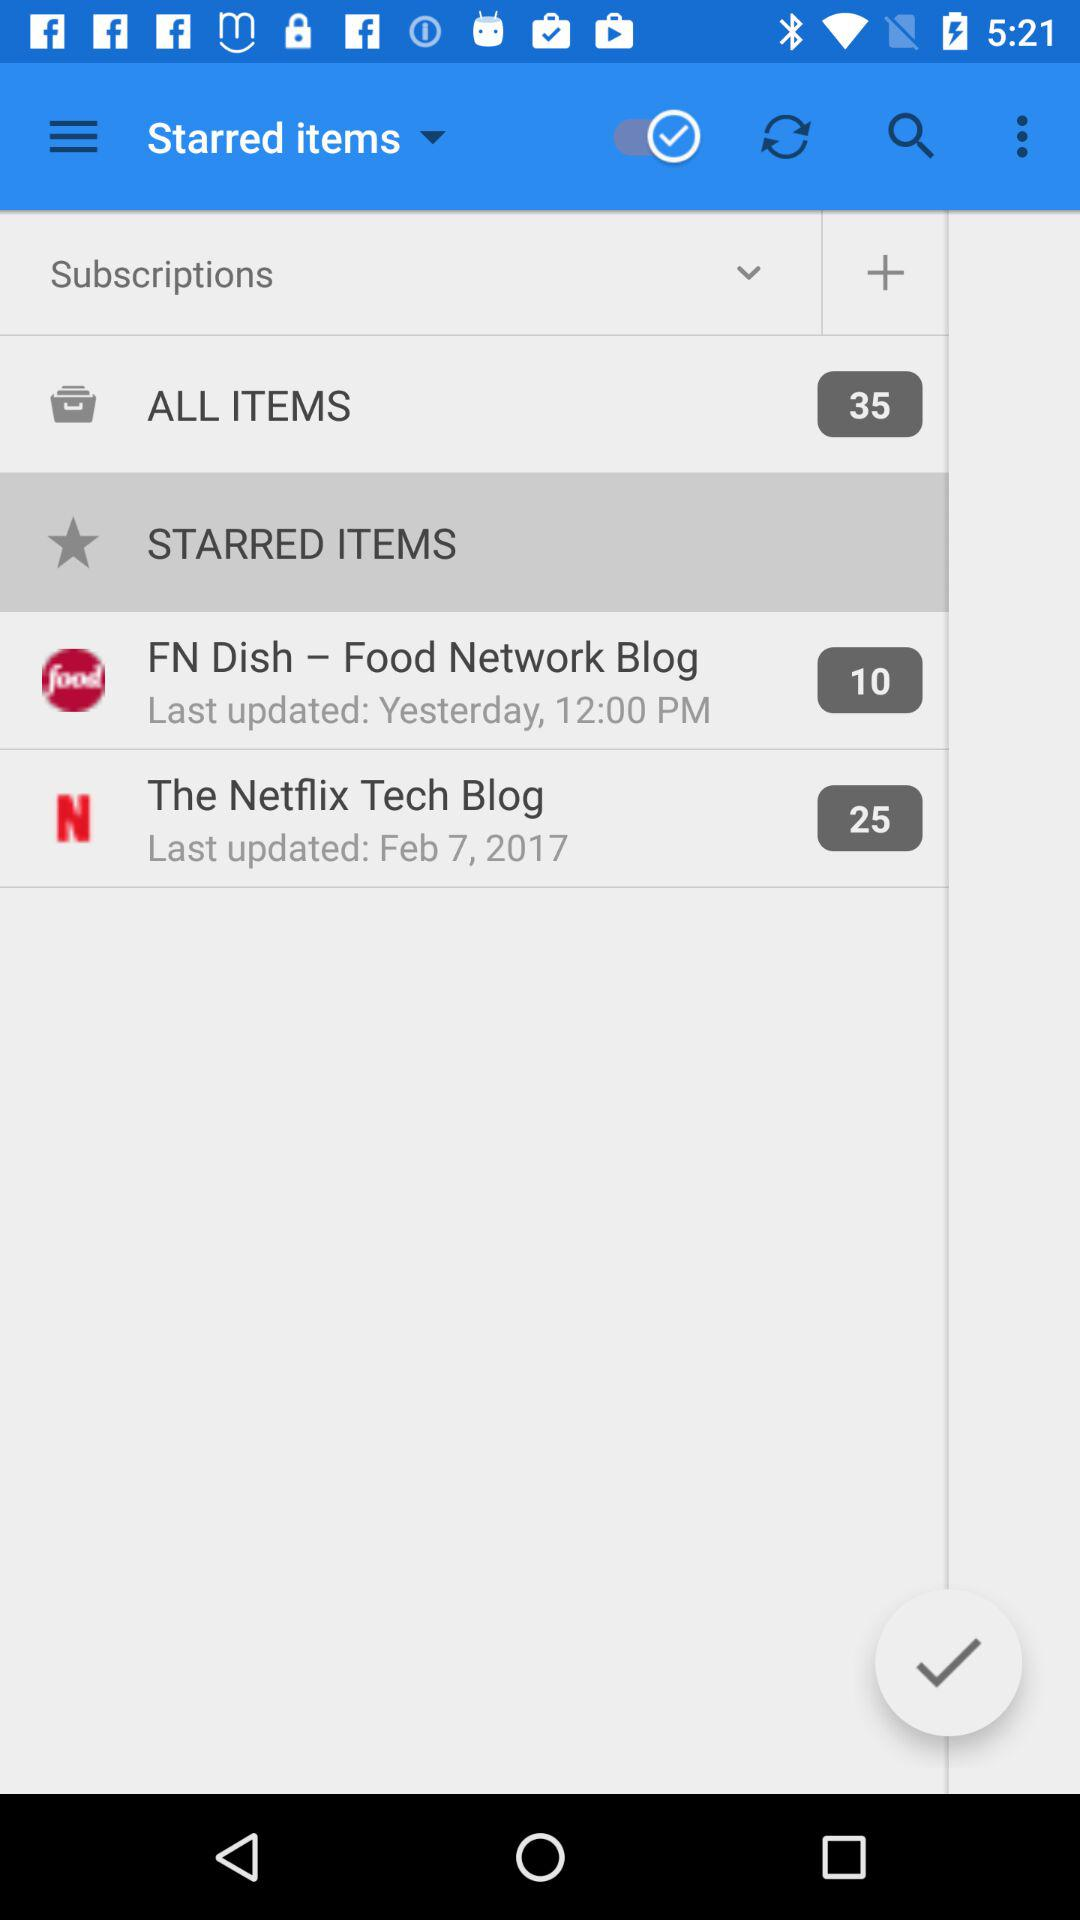When was "The Netflix Tech Blog" last updated? "The Netflix Tech Blog" was last updated on February 7, 2017. 